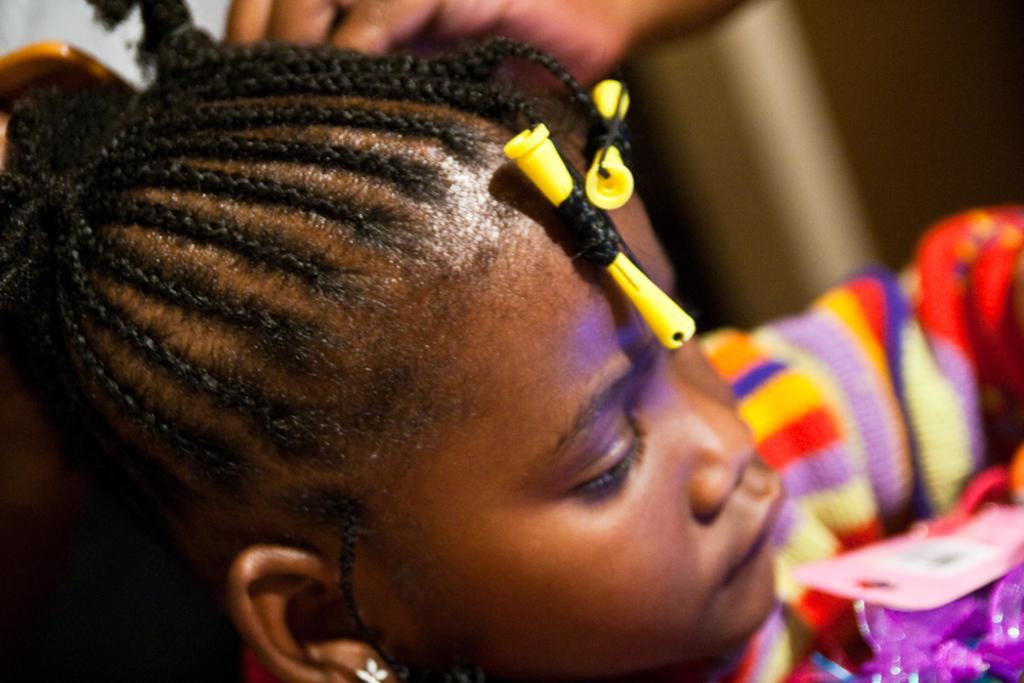Please provide a concise description of this image. In this image, we can see a girl. Background we can see a blur view. Here we can see human hand. Right side bottom corner, we can see a color paper and tag. In the middle of the image, we can see hair styling accessories. 